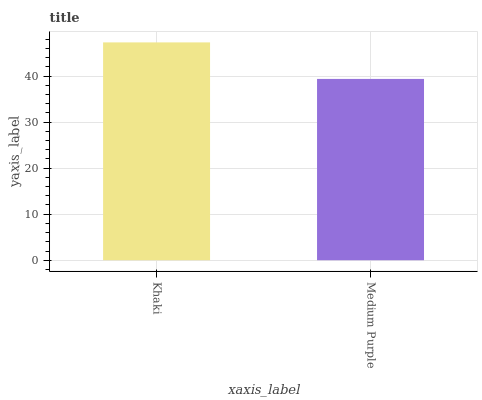Is Medium Purple the minimum?
Answer yes or no. Yes. Is Khaki the maximum?
Answer yes or no. Yes. Is Medium Purple the maximum?
Answer yes or no. No. Is Khaki greater than Medium Purple?
Answer yes or no. Yes. Is Medium Purple less than Khaki?
Answer yes or no. Yes. Is Medium Purple greater than Khaki?
Answer yes or no. No. Is Khaki less than Medium Purple?
Answer yes or no. No. Is Khaki the high median?
Answer yes or no. Yes. Is Medium Purple the low median?
Answer yes or no. Yes. Is Medium Purple the high median?
Answer yes or no. No. Is Khaki the low median?
Answer yes or no. No. 